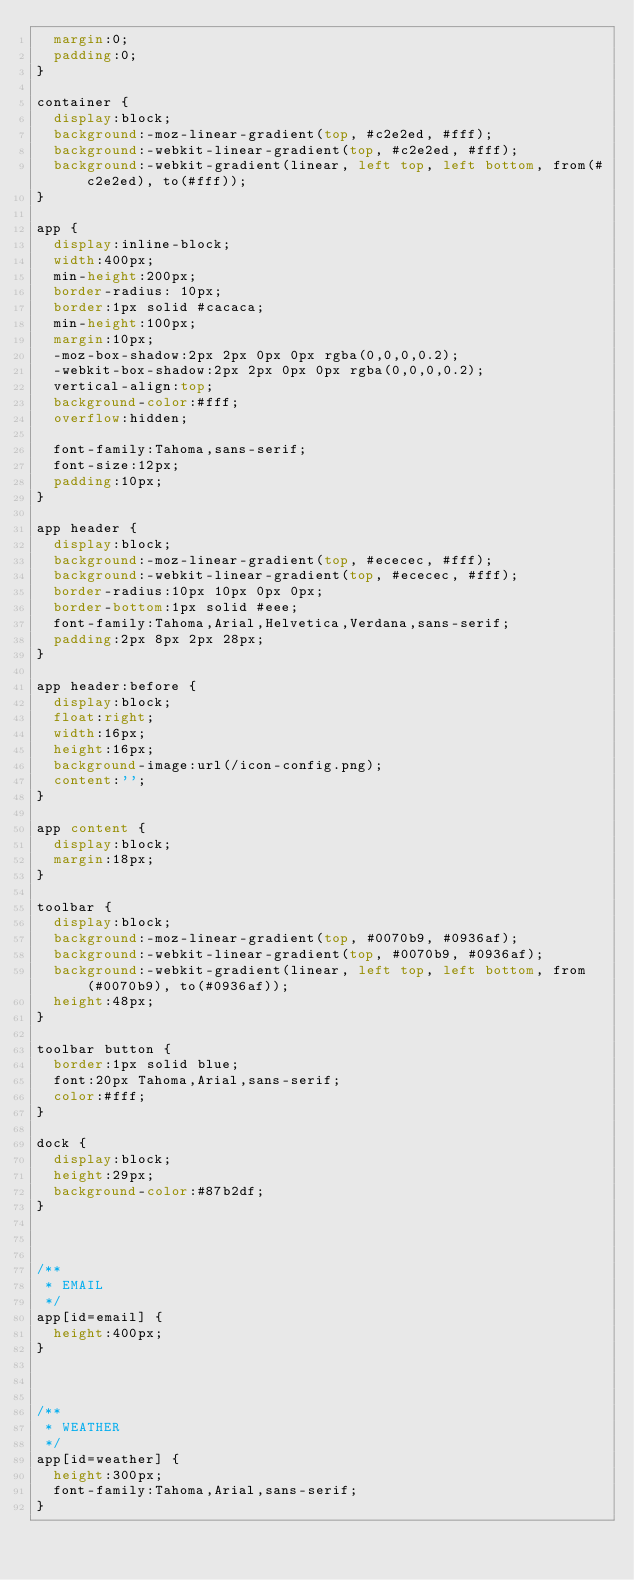<code> <loc_0><loc_0><loc_500><loc_500><_CSS_>	margin:0;
	padding:0;	
}

container {
	display:block;
	background:-moz-linear-gradient(top, #c2e2ed, #fff);
	background:-webkit-linear-gradient(top, #c2e2ed, #fff);
	background:-webkit-gradient(linear, left top, left bottom, from(#c2e2ed), to(#fff));
}

app {
	display:inline-block;
	width:400px;
	min-height:200px; 
	border-radius: 10px;
	border:1px solid #cacaca;
	min-height:100px;
	margin:10px;
	-moz-box-shadow:2px 2px 0px 0px rgba(0,0,0,0.2);
	-webkit-box-shadow:2px 2px 0px 0px rgba(0,0,0,0.2);
	vertical-align:top;
	background-color:#fff;
	overflow:hidden;

	font-family:Tahoma,sans-serif;
	font-size:12px;
	padding:10px;
}

app header {
	display:block;
	background:-moz-linear-gradient(top, #ececec, #fff);
	background:-webkit-linear-gradient(top, #ececec, #fff);
	border-radius:10px 10px 0px 0px;
	border-bottom:1px solid #eee;
	font-family:Tahoma,Arial,Helvetica,Verdana,sans-serif;
	padding:2px 8px 2px 28px;
}

app header:before {
	display:block;
	float:right;
	width:16px;
	height:16px;
	background-image:url(/icon-config.png);
	content:'';
}

app content {
	display:block;
	margin:18px;
}

toolbar {
	display:block;
	background:-moz-linear-gradient(top, #0070b9, #0936af);
	background:-webkit-linear-gradient(top, #0070b9, #0936af);
	background:-webkit-gradient(linear, left top, left bottom, from(#0070b9), to(#0936af));
	height:48px;
}

toolbar button {
	border:1px solid blue;
	font:20px Tahoma,Arial,sans-serif;
	color:#fff;
}

dock {
	display:block;
	height:29px;
	background-color:#87b2df;
}



/**
 * EMAIL 
 */
app[id=email] {
	height:400px;
}



/**
 * WEATHER
 */
app[id=weather] {
	height:300px;
	font-family:Tahoma,Arial,sans-serif;
}</code> 